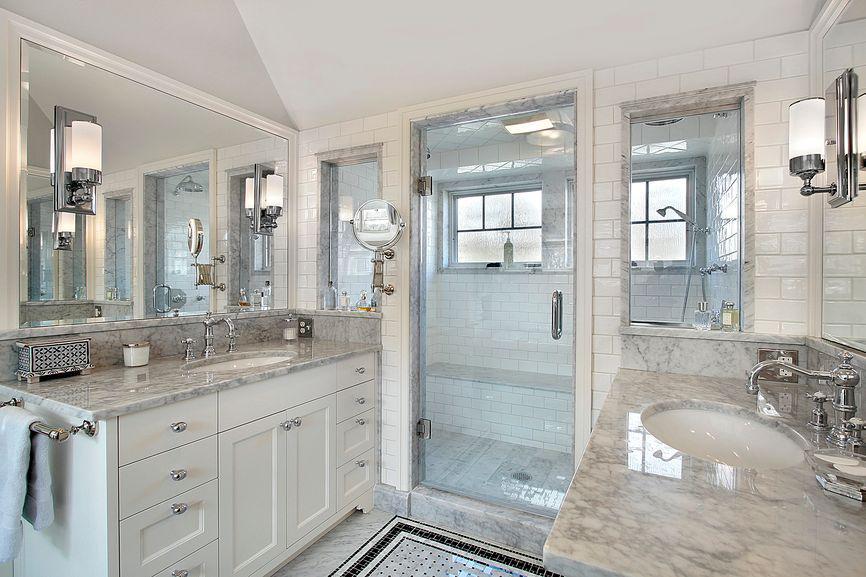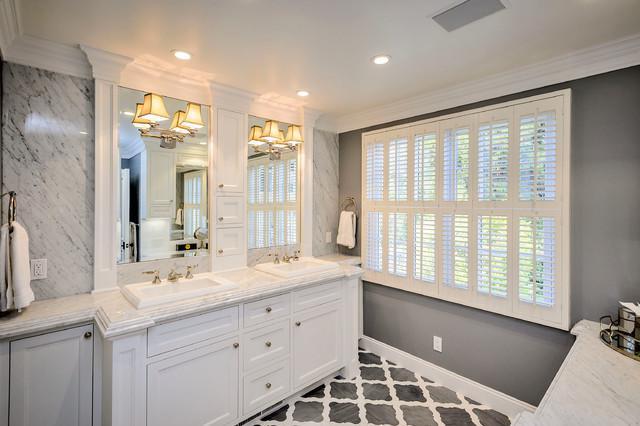The first image is the image on the left, the second image is the image on the right. For the images shown, is this caption "One image shows a seamless mirror over an undivided white 'trough' sink with multiple spouts over it, which has a white toilet with a tank behind it." true? Answer yes or no. No. The first image is the image on the left, the second image is the image on the right. For the images shown, is this caption "There are four sink faucets" true? Answer yes or no. Yes. 